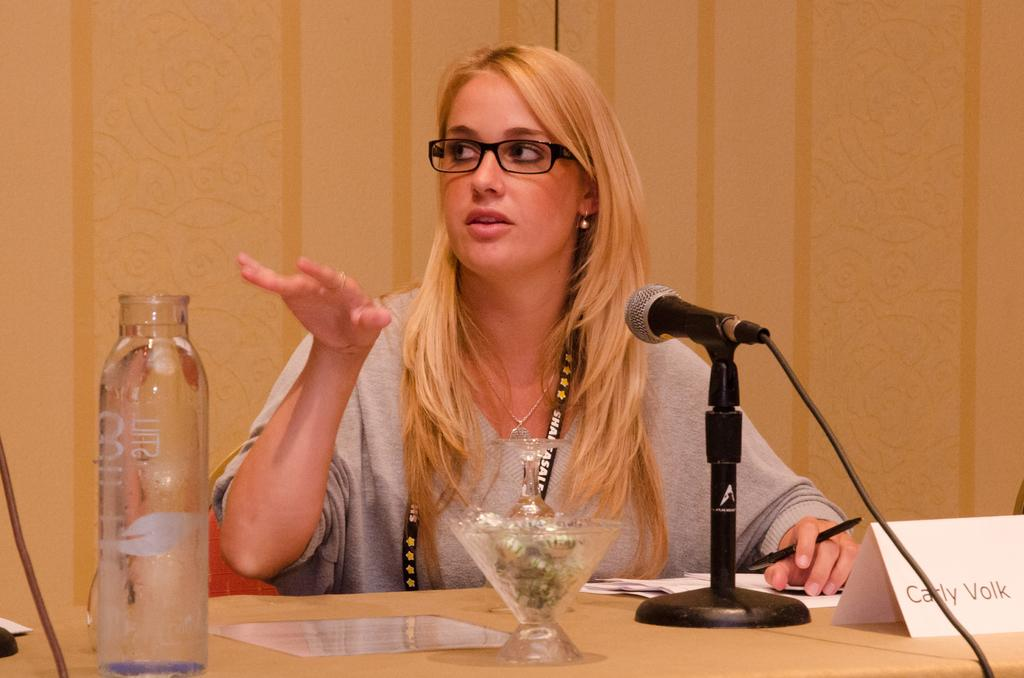Who is the main subject in the image? There is a woman in the image. What is the woman doing in the image? The woman is looking at someone else. What object is in front of the woman? There is a microphone in front of the woman. Can you tell me how many times the woman bites her nails in the image? There is no indication in the image that the woman is biting her nails, so it cannot be determined from the picture. 